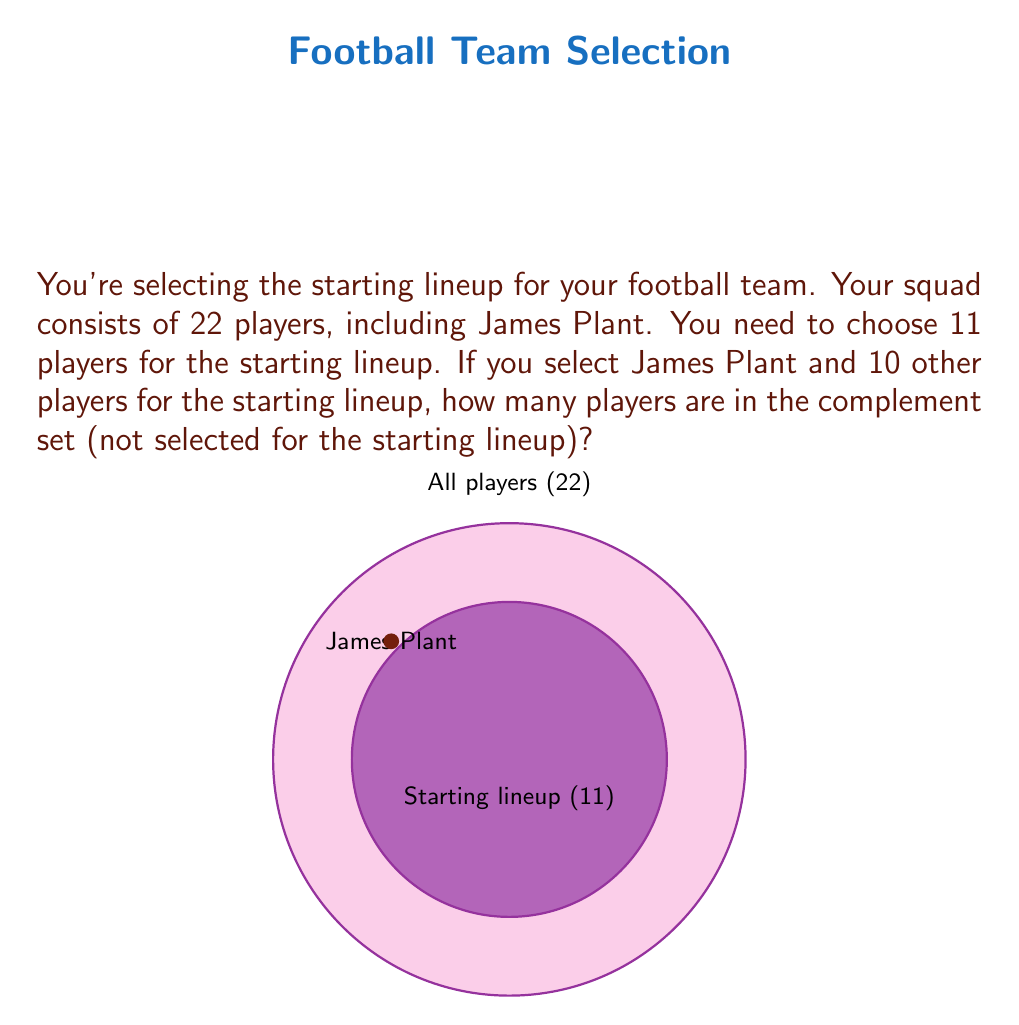Teach me how to tackle this problem. Let's approach this step-by-step:

1) First, let's define our sets:
   $U$ = Universal set (all players in the squad)
   $S$ = Set of players in the starting lineup
   $S'$ = Complement of S (players not in the starting lineup)

2) We know that:
   $|U| = 22$ (total number of players)
   $|S| = 11$ (number of players in the starting lineup)

3) To find the complement set $S'$, we use the formula:
   $|S'| = |U| - |S|$

4) Substituting the values:
   $|S'| = 22 - 11$

5) Calculating:
   $|S'| = 11$

Therefore, there are 11 players in the complement set, i.e., not selected for the starting lineup.
Answer: 11 